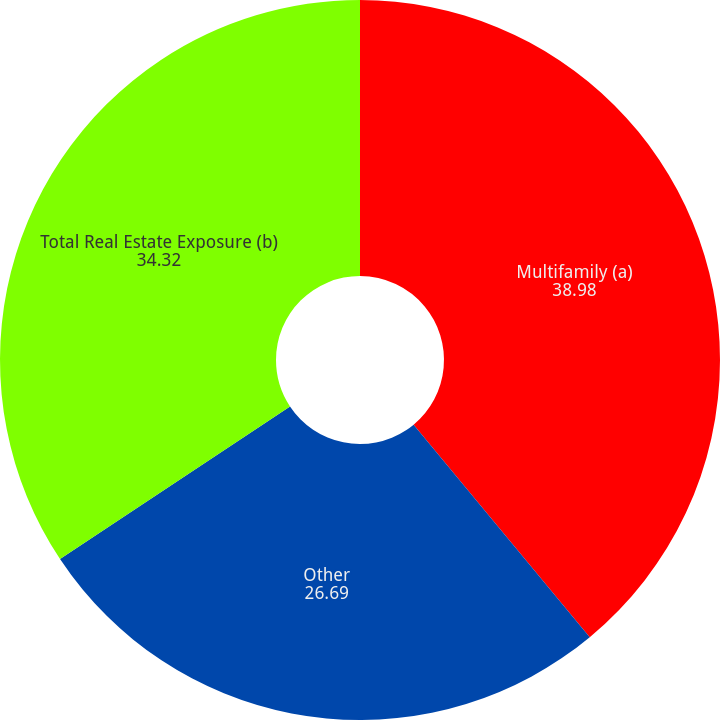<chart> <loc_0><loc_0><loc_500><loc_500><pie_chart><fcel>Multifamily (a)<fcel>Other<fcel>Total Real Estate Exposure (b)<nl><fcel>38.98%<fcel>26.69%<fcel>34.32%<nl></chart> 